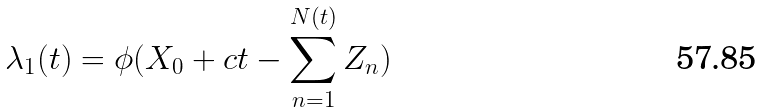<formula> <loc_0><loc_0><loc_500><loc_500>\lambda _ { 1 } ( t ) = \phi ( X _ { 0 } + c t - \sum _ { n = 1 } ^ { N ( t ) } Z _ { n } )</formula> 